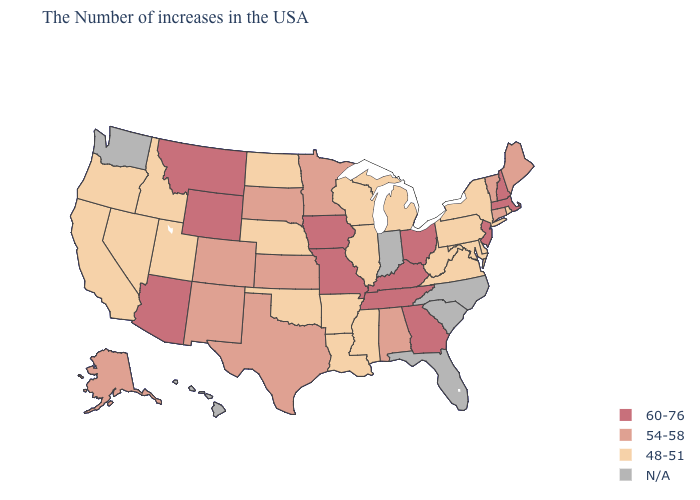Which states have the lowest value in the USA?
Write a very short answer. Rhode Island, New York, Delaware, Maryland, Pennsylvania, Virginia, West Virginia, Michigan, Wisconsin, Illinois, Mississippi, Louisiana, Arkansas, Nebraska, Oklahoma, North Dakota, Utah, Idaho, Nevada, California, Oregon. What is the lowest value in states that border Maine?
Keep it brief. 60-76. What is the lowest value in the USA?
Answer briefly. 48-51. Which states have the lowest value in the Northeast?
Give a very brief answer. Rhode Island, New York, Pennsylvania. What is the highest value in states that border Connecticut?
Give a very brief answer. 60-76. What is the lowest value in states that border Iowa?
Write a very short answer. 48-51. What is the value of North Carolina?
Write a very short answer. N/A. Name the states that have a value in the range N/A?
Write a very short answer. North Carolina, South Carolina, Florida, Indiana, Washington, Hawaii. Which states have the highest value in the USA?
Give a very brief answer. Massachusetts, New Hampshire, New Jersey, Ohio, Georgia, Kentucky, Tennessee, Missouri, Iowa, Wyoming, Montana, Arizona. What is the lowest value in the Northeast?
Answer briefly. 48-51. Which states hav the highest value in the South?
Quick response, please. Georgia, Kentucky, Tennessee. What is the value of Minnesota?
Answer briefly. 54-58. Does the first symbol in the legend represent the smallest category?
Give a very brief answer. No. 